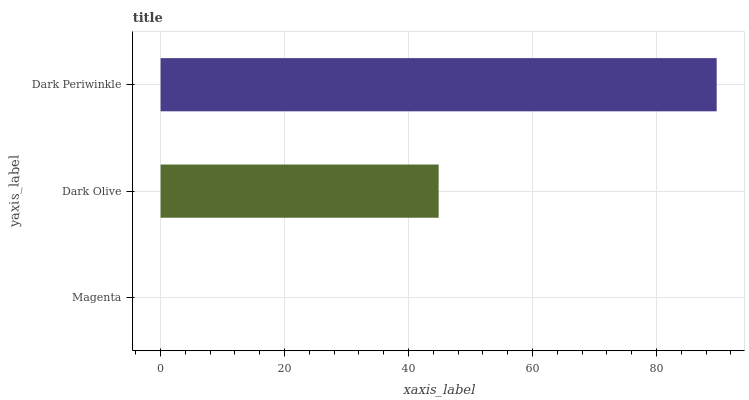Is Magenta the minimum?
Answer yes or no. Yes. Is Dark Periwinkle the maximum?
Answer yes or no. Yes. Is Dark Olive the minimum?
Answer yes or no. No. Is Dark Olive the maximum?
Answer yes or no. No. Is Dark Olive greater than Magenta?
Answer yes or no. Yes. Is Magenta less than Dark Olive?
Answer yes or no. Yes. Is Magenta greater than Dark Olive?
Answer yes or no. No. Is Dark Olive less than Magenta?
Answer yes or no. No. Is Dark Olive the high median?
Answer yes or no. Yes. Is Dark Olive the low median?
Answer yes or no. Yes. Is Magenta the high median?
Answer yes or no. No. Is Dark Periwinkle the low median?
Answer yes or no. No. 